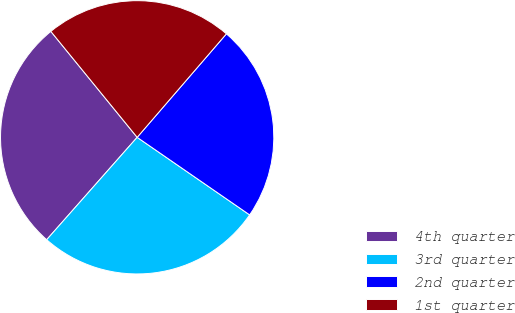Convert chart. <chart><loc_0><loc_0><loc_500><loc_500><pie_chart><fcel>4th quarter<fcel>3rd quarter<fcel>2nd quarter<fcel>1st quarter<nl><fcel>27.6%<fcel>26.91%<fcel>23.28%<fcel>22.21%<nl></chart> 